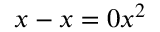<formula> <loc_0><loc_0><loc_500><loc_500>x - x = 0 x ^ { 2 }</formula> 